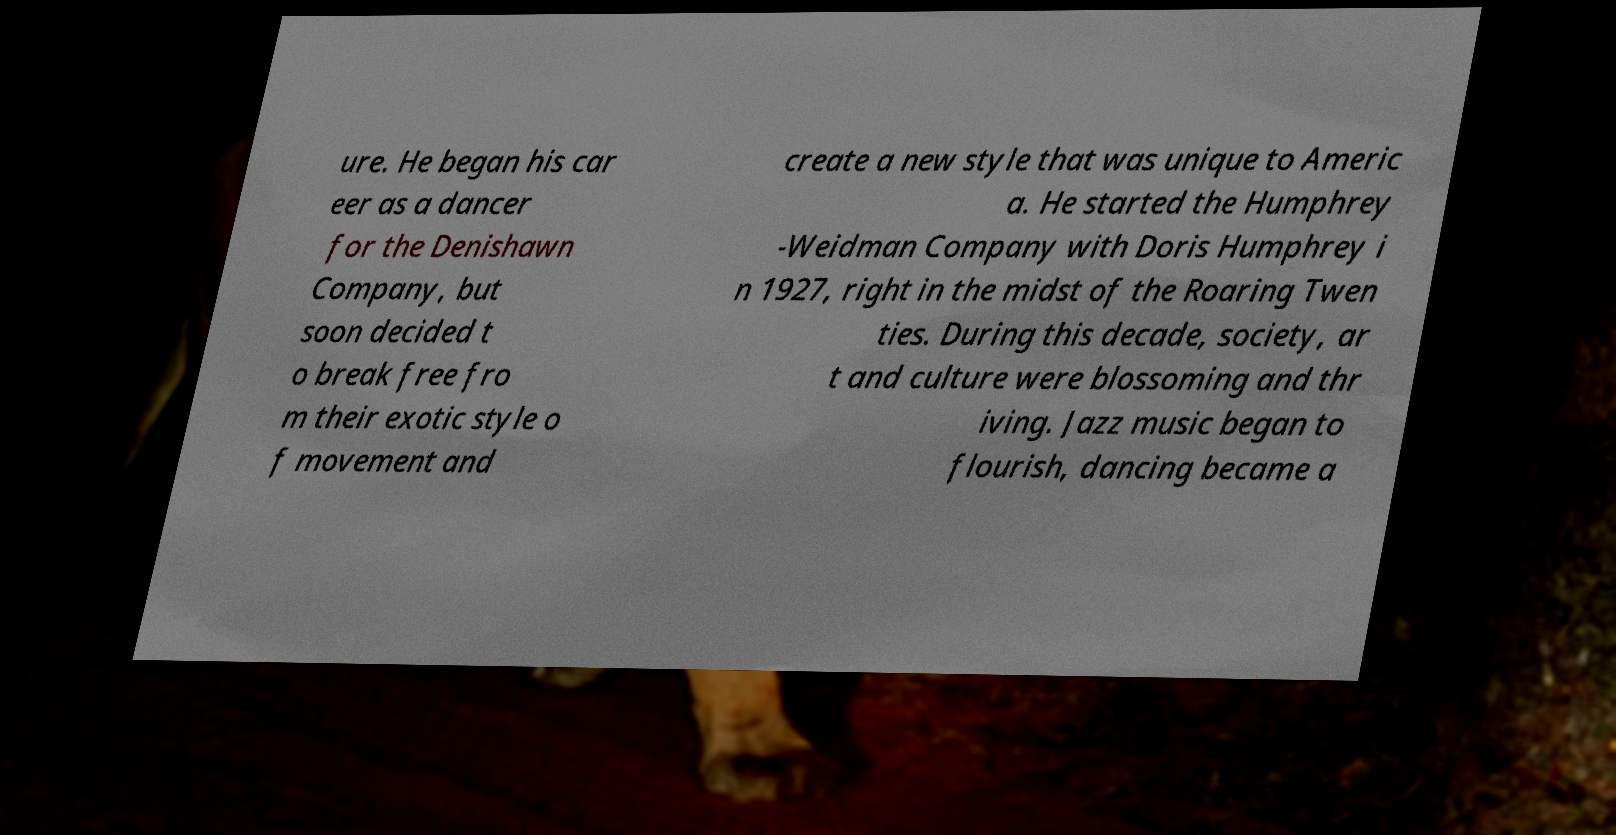Please identify and transcribe the text found in this image. ure. He began his car eer as a dancer for the Denishawn Company, but soon decided t o break free fro m their exotic style o f movement and create a new style that was unique to Americ a. He started the Humphrey -Weidman Company with Doris Humphrey i n 1927, right in the midst of the Roaring Twen ties. During this decade, society, ar t and culture were blossoming and thr iving. Jazz music began to flourish, dancing became a 